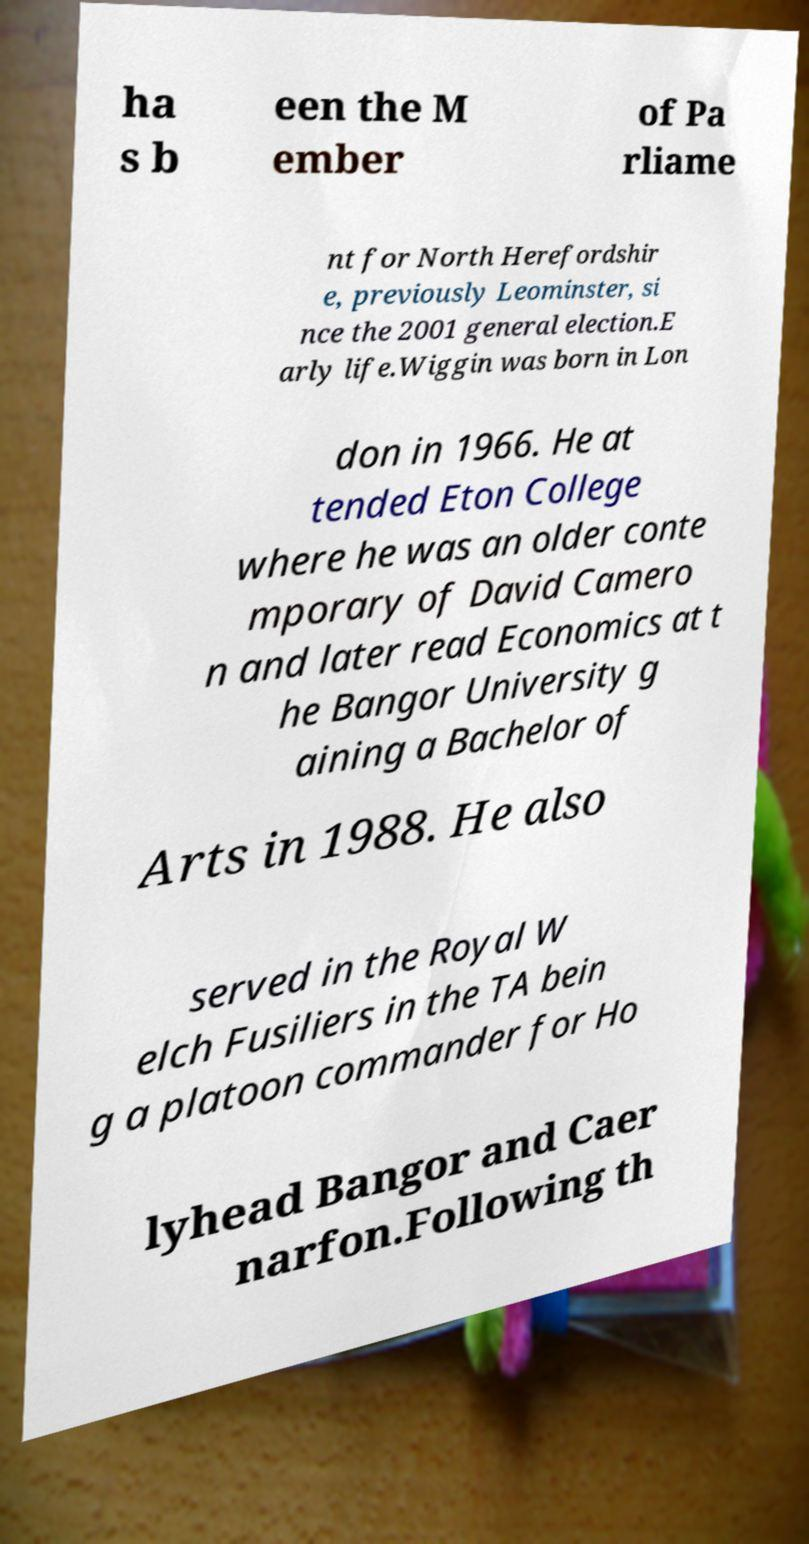What messages or text are displayed in this image? I need them in a readable, typed format. ha s b een the M ember of Pa rliame nt for North Herefordshir e, previously Leominster, si nce the 2001 general election.E arly life.Wiggin was born in Lon don in 1966. He at tended Eton College where he was an older conte mporary of David Camero n and later read Economics at t he Bangor University g aining a Bachelor of Arts in 1988. He also served in the Royal W elch Fusiliers in the TA bein g a platoon commander for Ho lyhead Bangor and Caer narfon.Following th 